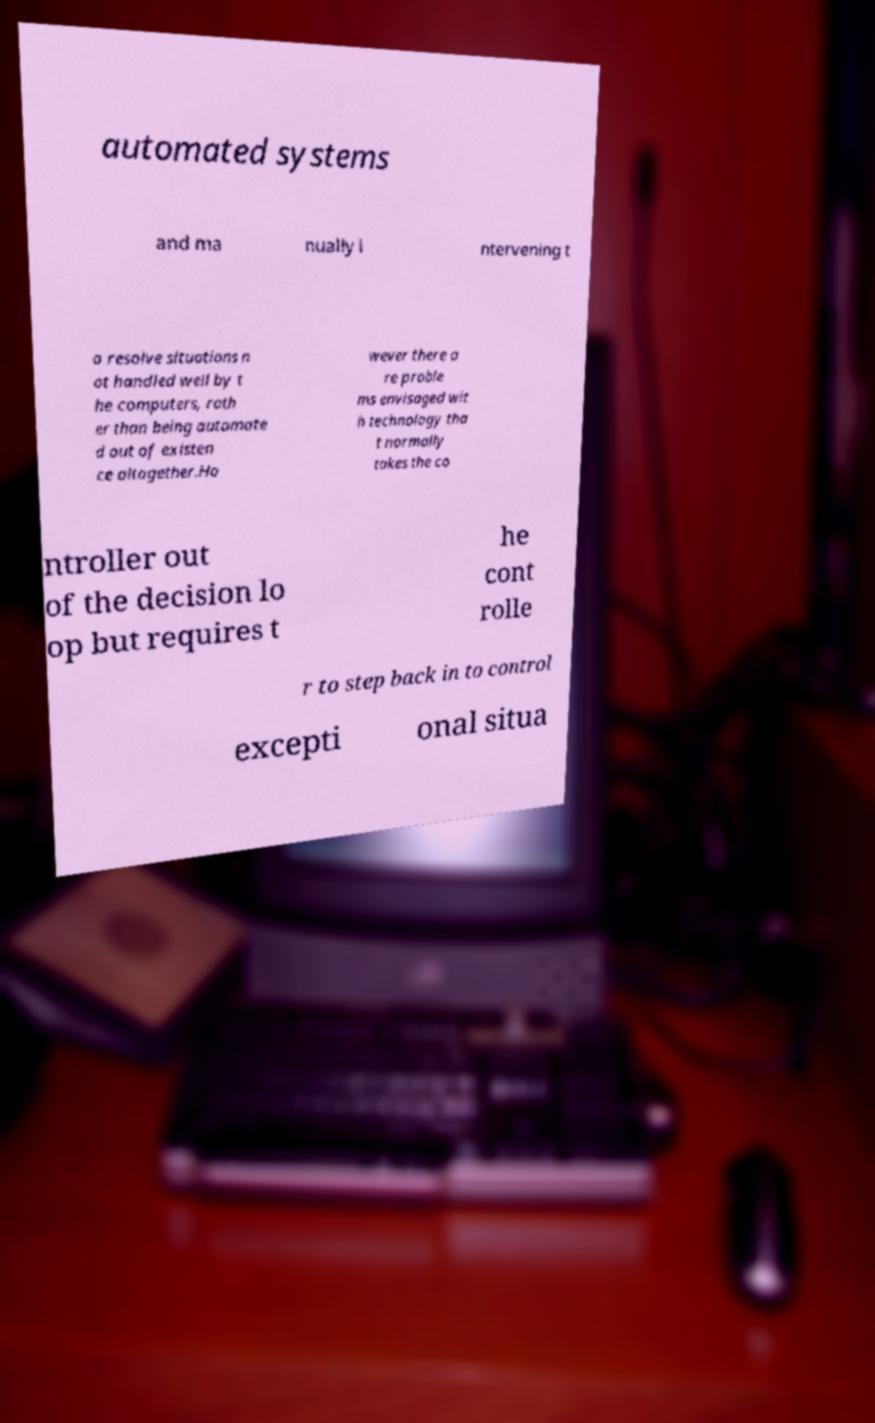Can you read and provide the text displayed in the image?This photo seems to have some interesting text. Can you extract and type it out for me? automated systems and ma nually i ntervening t o resolve situations n ot handled well by t he computers, rath er than being automate d out of existen ce altogether.Ho wever there a re proble ms envisaged wit h technology tha t normally takes the co ntroller out of the decision lo op but requires t he cont rolle r to step back in to control excepti onal situa 